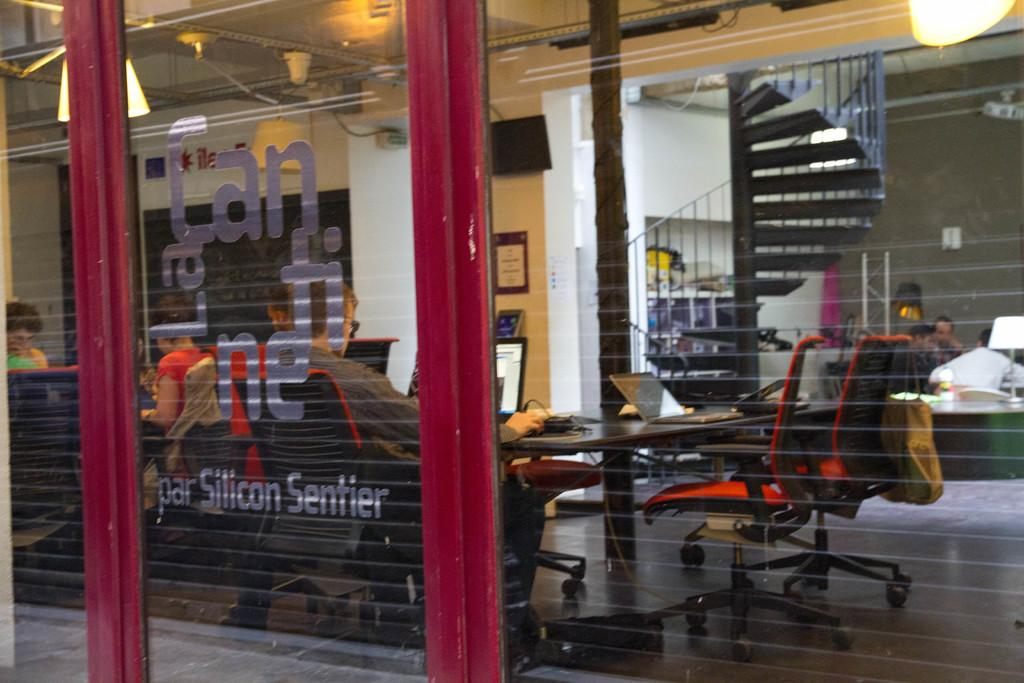Provide a one-sentence caption for the provided image. outside a buliding with Par Silicon Sentier on the window. 